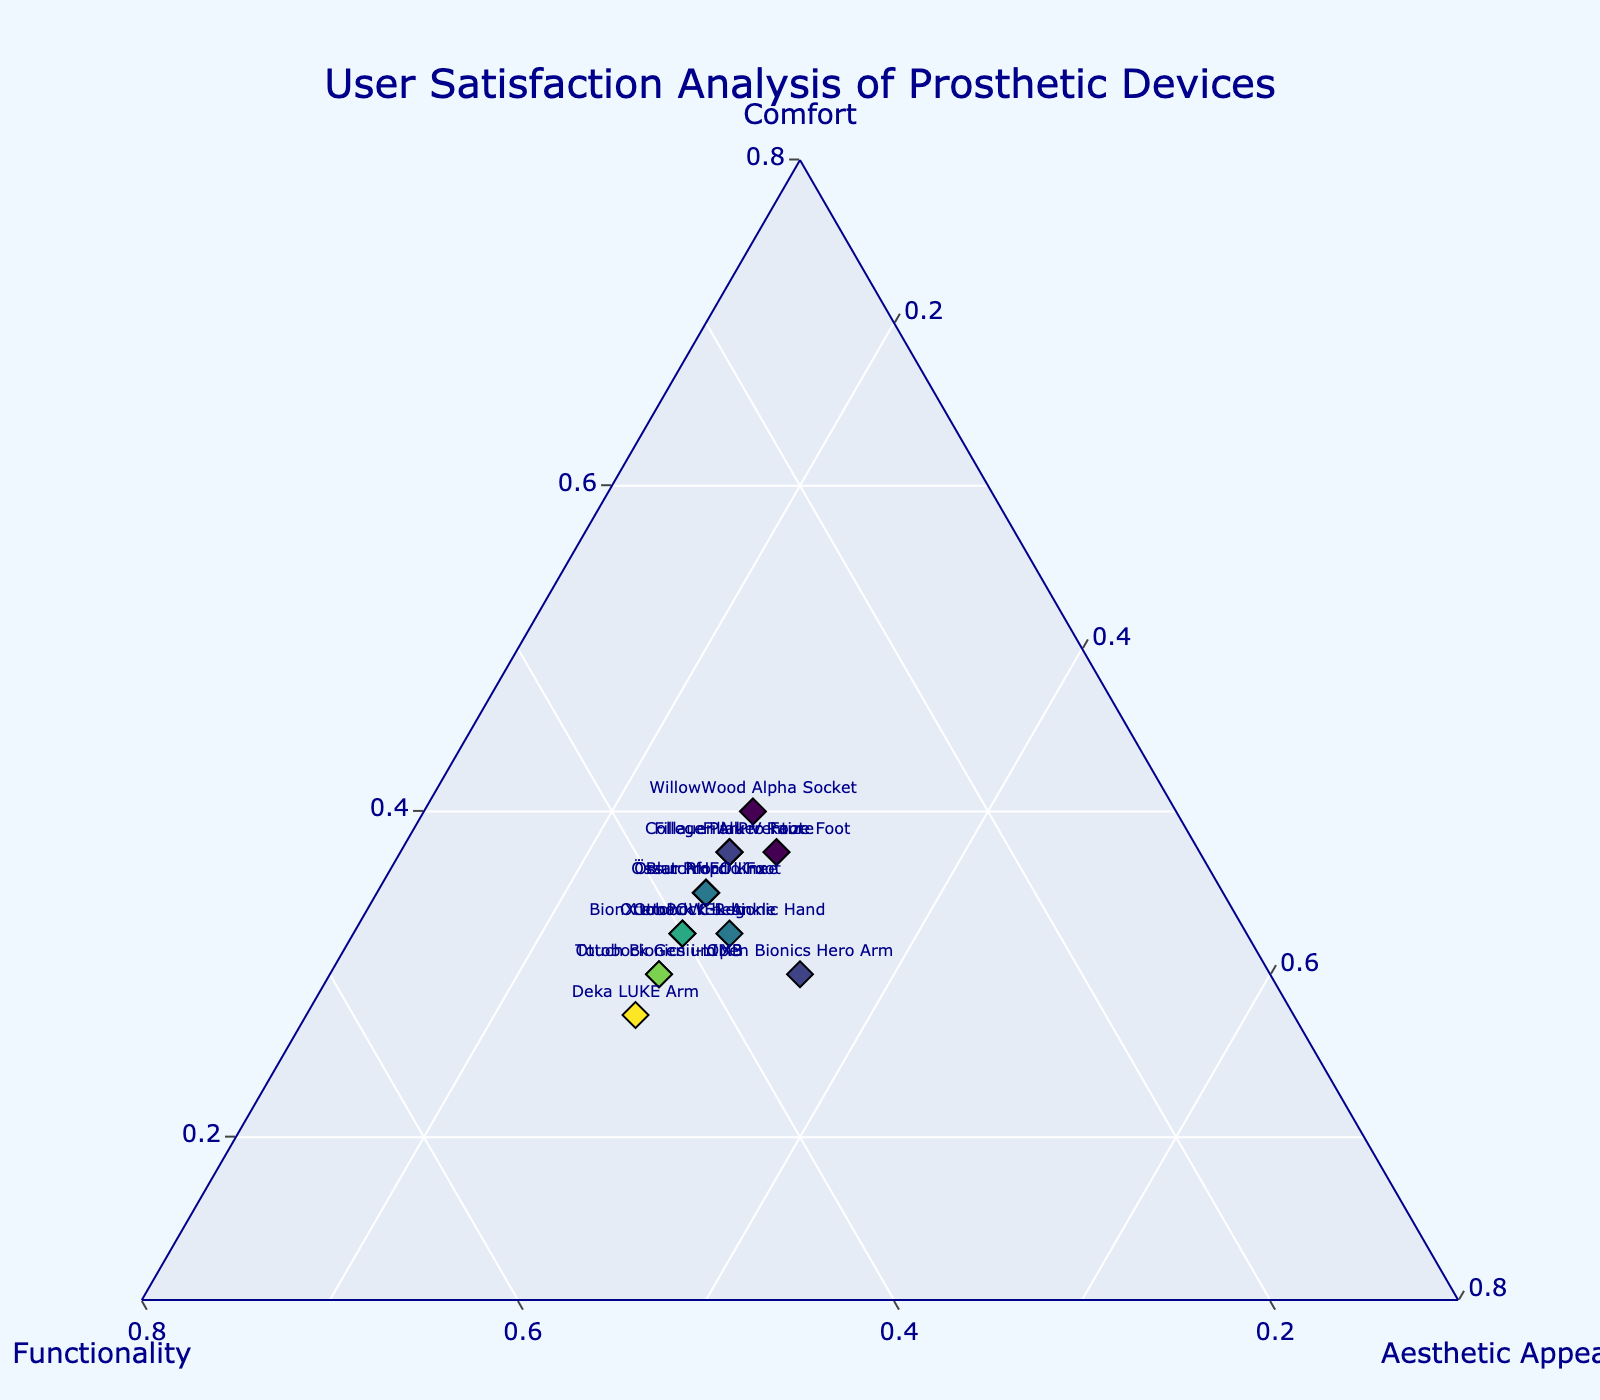How many prosthetic devices are analyzed in the ternary plot? There are distinct data points for each prosthetic device visible in the plot. By counting the labeled points, we get a total of 14 devices.
Answer: 14 What is the title of the plot? The title of the plot is prominently displayed at the top and reads "User Satisfaction Analysis of Prosthetic Devices".
Answer: User Satisfaction Analysis of Prosthetic Devices Which device has the highest satisfaction in terms of comfort? The device located closest to the 'Comfort' axis (A) has the highest satisfaction in terms of comfort. The 'WillowWood Alpha Socket' has the highest 'Comfort' value at 0.80.
Answer: WillowWood Alpha Socket Which device has the lowest functionality rating? The device furthest from the 'Functionality' axis (B) has the lowest functionality rating. The 'WillowWood Alpha Socket' has the lowest 'Functionality' value at 0.65.
Answer: WillowWood Alpha Socket How do the 'Ottobock C-Leg' and 'Ottobock bebionic Hand' compare in their comfort ratings? By observing the proximity to the 'Comfort' axis, 'Ottobock C-Leg' (0.65) is slightly higher than 'Ottobock bebionic Hand' (0.65).
Answer: Equivalent Which devices have an identical aesthetic appeal rating? By looking at the labels near the 'Aesthetic Appeal' axis (C), multiple devices (Names can be mentioned) appear to share a value. 'Ottobock C-Leg', 'Össur Proprio Foot', and several others have an identical rating of 0.55.
Answer: Ottobock C-Leg, Össur Proprio Foot, Touch Bionics i-LIMB, Fillauer AllPro Foot, Deka LUKE Arm, Blatchford Linx, WillowWood Alpha Socket, College Park Venture, BionX emPOWER Ankle, Össur RHEO Knee What is unique about the 'Open Bionics Hero Arm' in terms of aesthetic appeal? The 'Open Bionics Hero Arm' is notable for being a bit separate from the others, having an 'Aesthetic Appeal' value of 0.70. It stands out among others rated at 0.55 and 0.60.
Answer: It has the highest aesthetic appeal rating How is comfort and functionality balanced in 'Ottobock Genium X3'? The 'Ottobock Genium X3' is positioned so that its 'Comfort' (0.60) and 'Functionality' (0.85) are balanced more towards functionality.
Answer: More towards functionality What can we infer about the overall satisfaction trend from the color gradient and positioning? Examining the color gradient (based on functionality ratings) and positioning relative to all three axes, it suggests that functionality tends to dominate user satisfaction, with fewer devices leaning more heavily towards comfort or aesthetic appeal alone.
Answer: Functionality dominates 